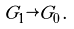Convert formula to latex. <formula><loc_0><loc_0><loc_500><loc_500>G _ { 1 } \rightarrow G _ { 0 } \, .</formula> 